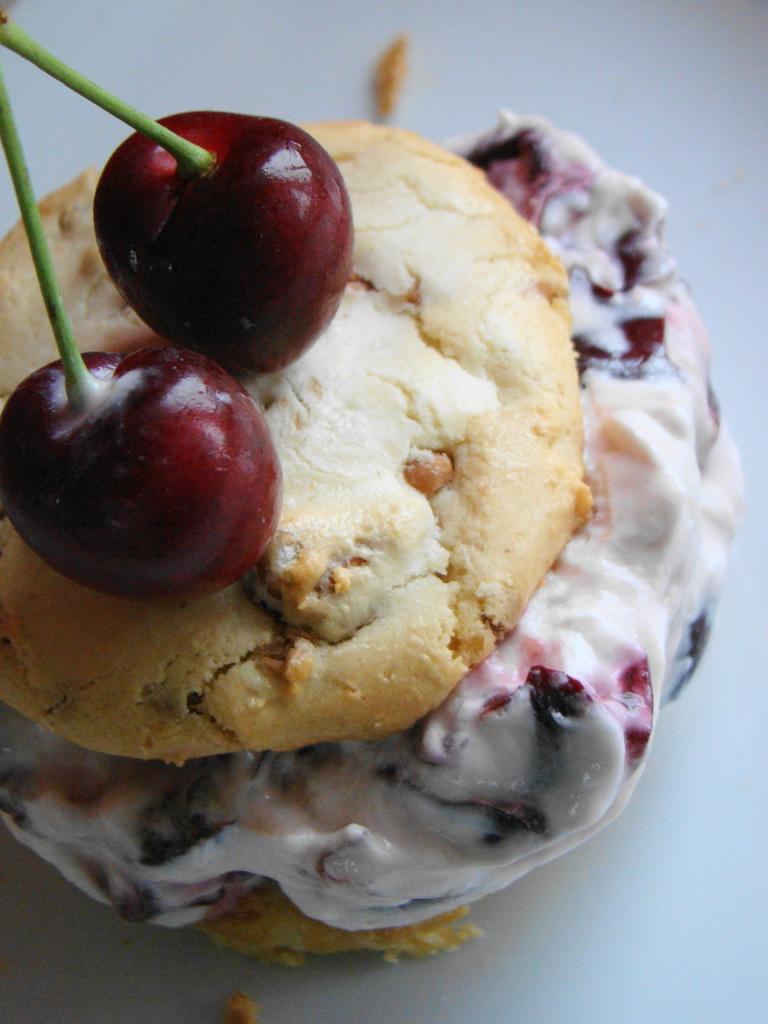In one or two sentences, can you explain what this image depicts? In this image, I can see two cherries with stems, which are kept on a food item. There is a white background. 